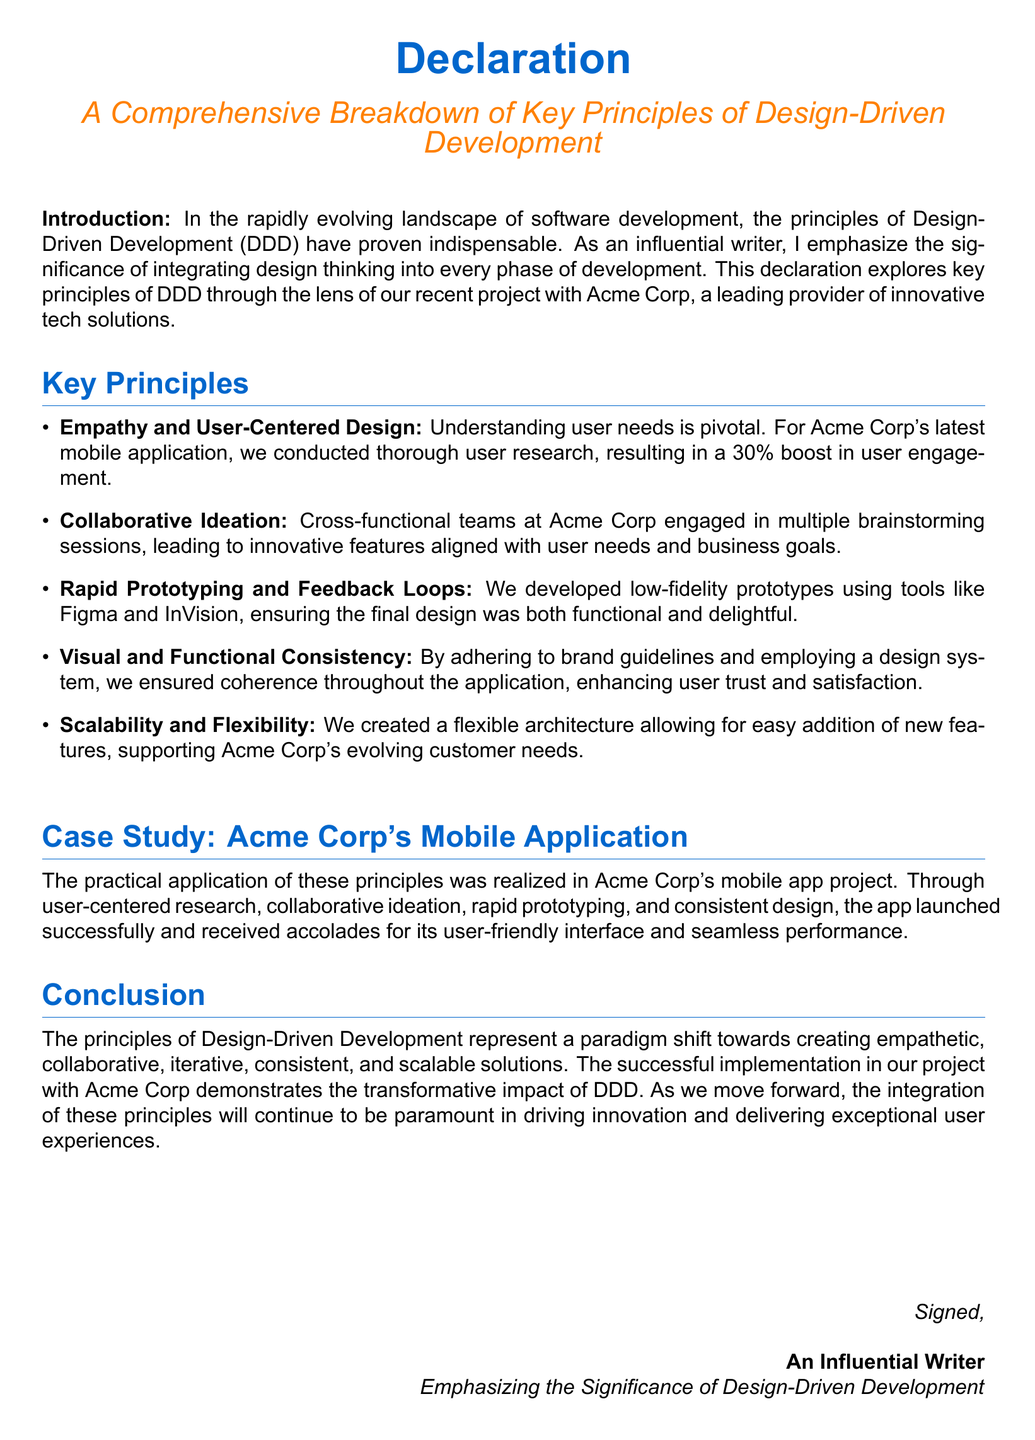What is the focus of this declaration? The focus of the declaration is the principles of Design-Driven Development (DDD) applied to a recent project.
Answer: Principles of Design-Driven Development What company was involved in the recent project? The declaration mentions Acme Corp as the company involved.
Answer: Acme Corp What percentage boost in user engagement resulted from user research? The document states that a 30% boost in user engagement was achieved.
Answer: 30% What tool was mentioned for rapid prototyping? The declaration lists Figma as one of the tools used for prototyping.
Answer: Figma Which design principle emphasizes understanding user needs? The principle related to understanding user needs is termed "Empathy and User-Centered Design".
Answer: Empathy and User-Centered Design How did cross-functional teams contribute to the project? They engaged in brainstorming sessions that led to innovative features.
Answer: Innovative features What was lauded about Acme Corp’s mobile application? The app was recognized for its user-friendly interface and seamless performance.
Answer: User-friendly interface and seamless performance What does the declaration imply about the future of DDD principles? It suggests that the integration of DDD principles will continue to be paramount.
Answer: Continue to be paramount What is the concluding sentiment of the declaration? The conclusion reflects the transformative impact of DDD principles.
Answer: Transformative impact of DDD principles 